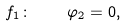Convert formula to latex. <formula><loc_0><loc_0><loc_500><loc_500>f _ { 1 } \colon \quad \varphi _ { 2 } = 0 ,</formula> 